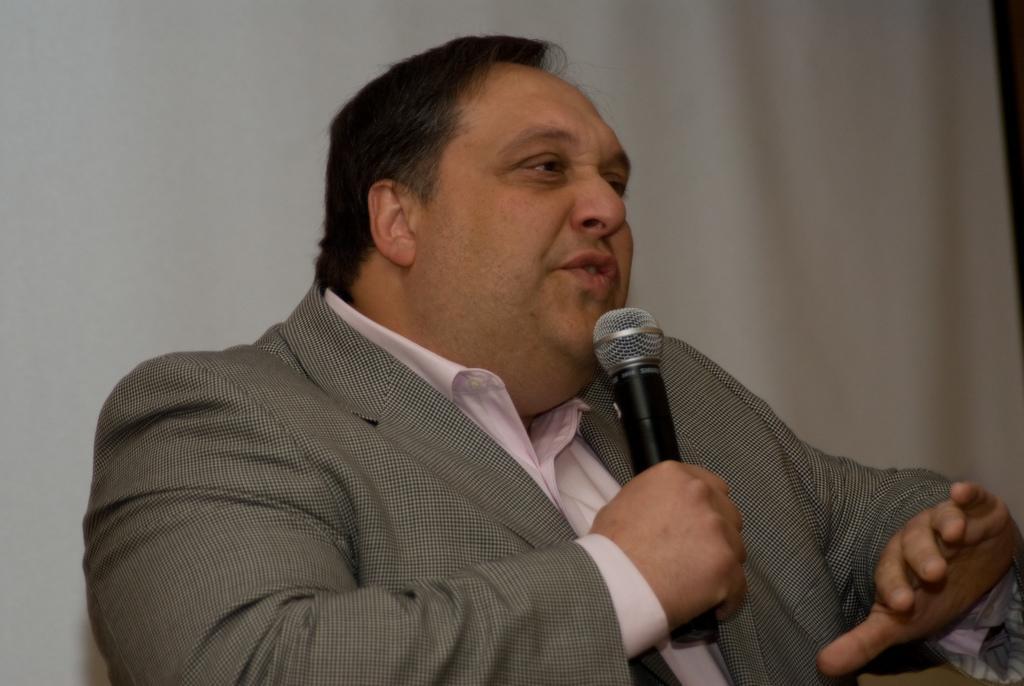Could you give a brief overview of what you see in this image? In this image a man wearing a suit is talking something. He is holding a mic. In the background there is a curtain. 